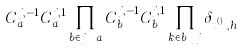<formula> <loc_0><loc_0><loc_500><loc_500>C _ { a } ^ { j , - 1 } C _ { a } ^ { j , 1 } \prod _ { b \in j \ a } C _ { b } ^ { j , - 1 } C _ { b } ^ { j , 1 } \prod _ { k \in b \ j } \delta _ { t _ { b } ^ { ( k ) } , h _ { k } }</formula> 